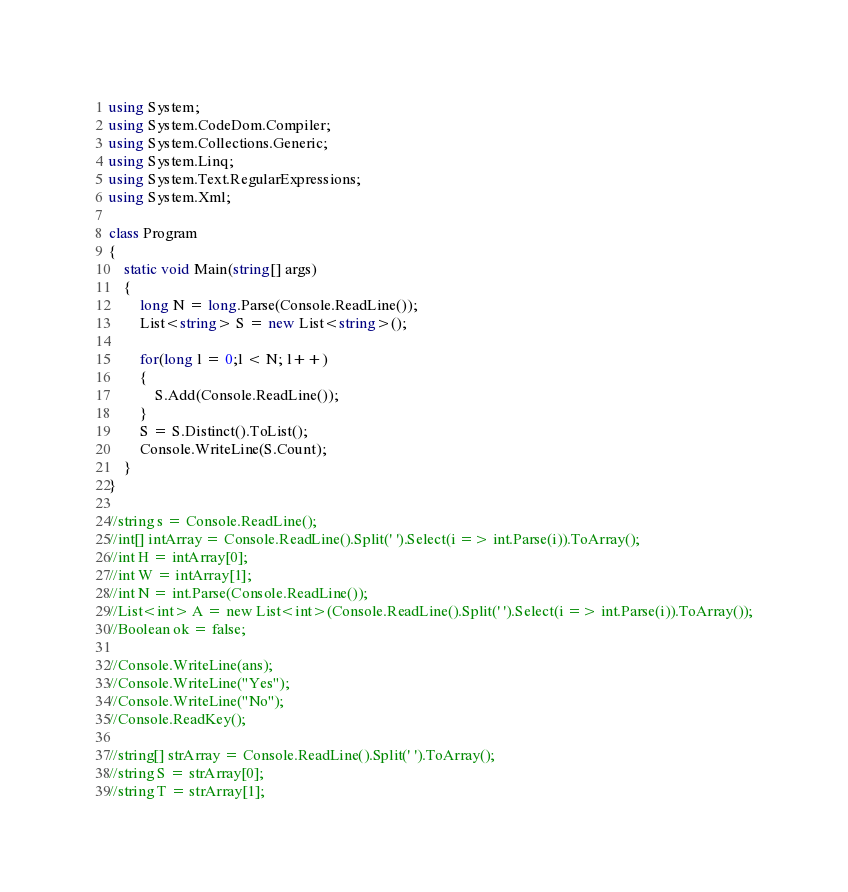<code> <loc_0><loc_0><loc_500><loc_500><_C#_>using System;
using System.CodeDom.Compiler;
using System.Collections.Generic;
using System.Linq;
using System.Text.RegularExpressions;
using System.Xml;

class Program
{
	static void Main(string[] args)
	{
		long N = long.Parse(Console.ReadLine());
		List<string> S = new List<string>();
		
		for(long l = 0;l < N; l++)
		{
			S.Add(Console.ReadLine());
		}
		S = S.Distinct().ToList();
		Console.WriteLine(S.Count);
	}
}

//string s = Console.ReadLine();
//int[] intArray = Console.ReadLine().Split(' ').Select(i => int.Parse(i)).ToArray();
//int H = intArray[0];
//int W = intArray[1];
//int N = int.Parse(Console.ReadLine());
//List<int> A = new List<int>(Console.ReadLine().Split(' ').Select(i => int.Parse(i)).ToArray());
//Boolean ok = false;

//Console.WriteLine(ans);
//Console.WriteLine("Yes");
//Console.WriteLine("No");
//Console.ReadKey();

//string[] strArray = Console.ReadLine().Split(' ').ToArray();
//string S = strArray[0];
//string T = strArray[1];
</code> 